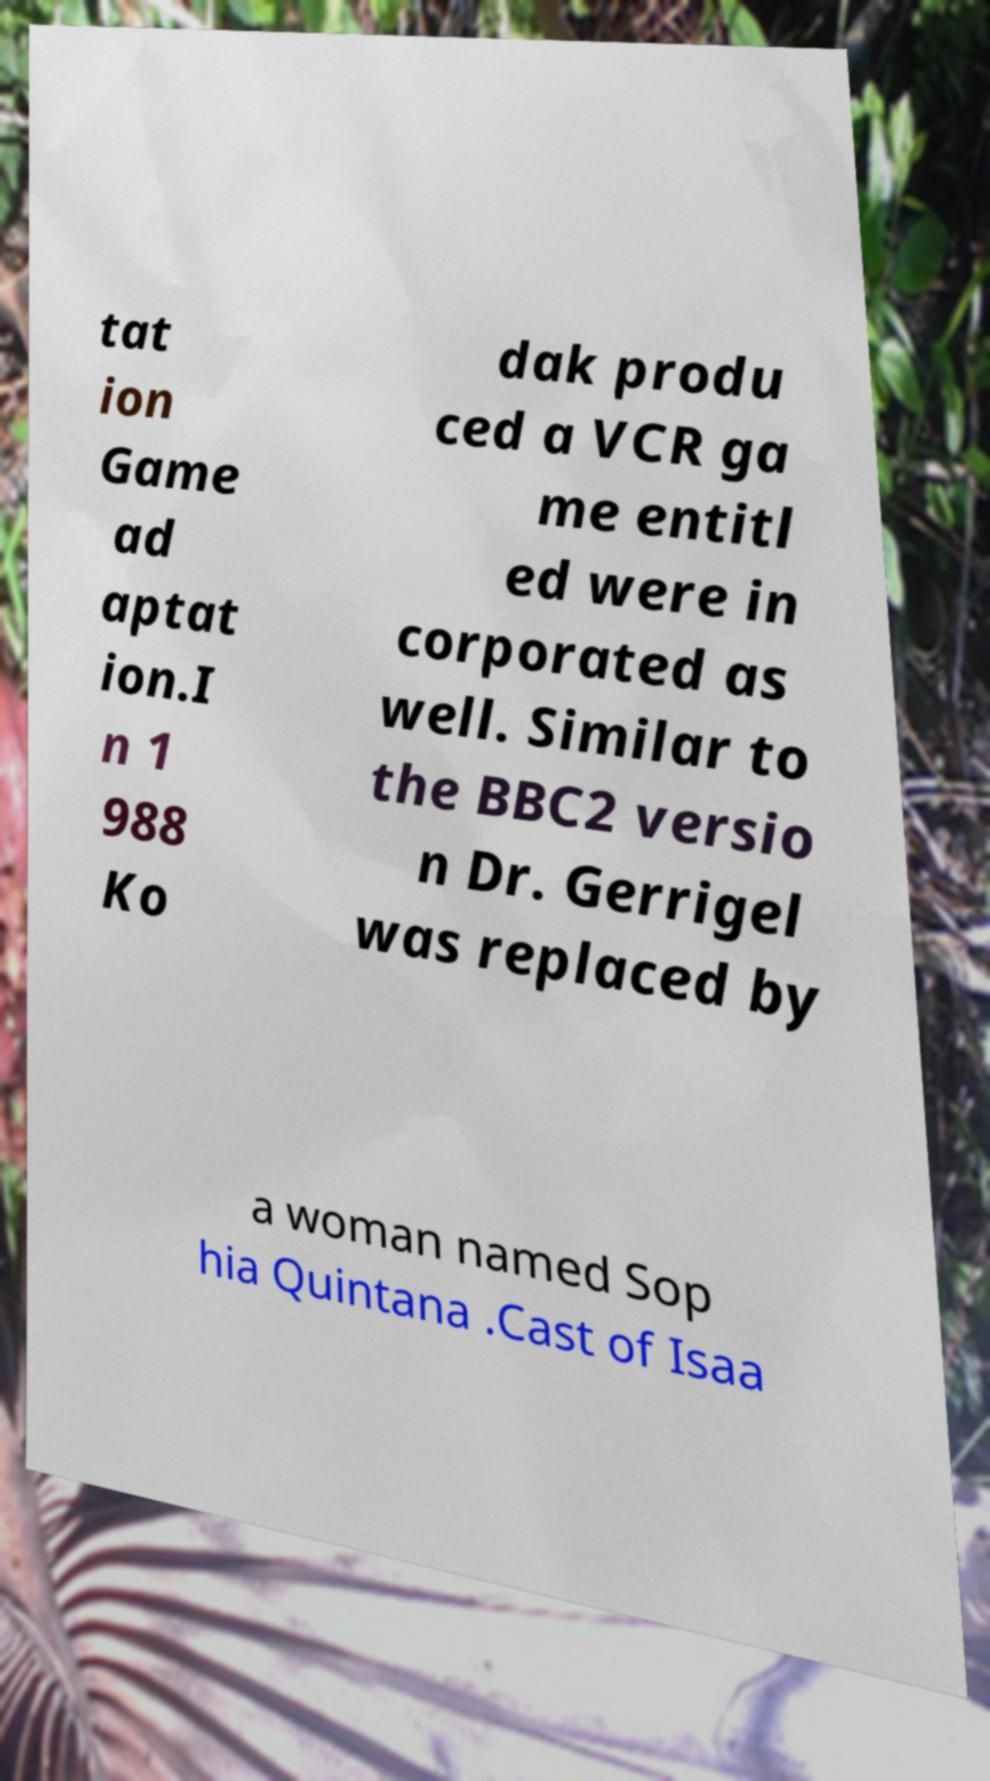Please identify and transcribe the text found in this image. tat ion Game ad aptat ion.I n 1 988 Ko dak produ ced a VCR ga me entitl ed were in corporated as well. Similar to the BBC2 versio n Dr. Gerrigel was replaced by a woman named Sop hia Quintana .Cast of Isaa 